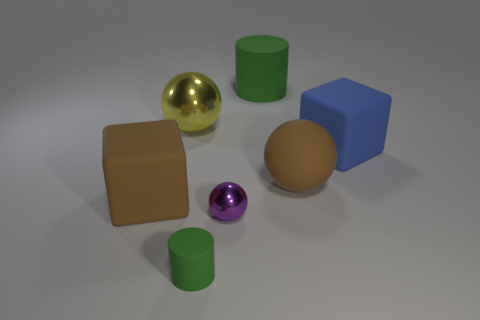Add 2 tiny yellow rubber cubes. How many objects exist? 9 Subtract all cubes. How many objects are left? 5 Add 7 big green matte objects. How many big green matte objects are left? 8 Add 5 balls. How many balls exist? 8 Subtract 0 blue balls. How many objects are left? 7 Subtract all small green things. Subtract all brown objects. How many objects are left? 4 